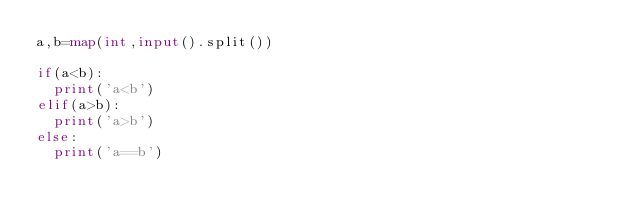<code> <loc_0><loc_0><loc_500><loc_500><_Python_>a,b=map(int,input().split())

if(a<b):
  print('a<b')
elif(a>b):
  print('a>b')
else:
  print('a==b')

</code> 